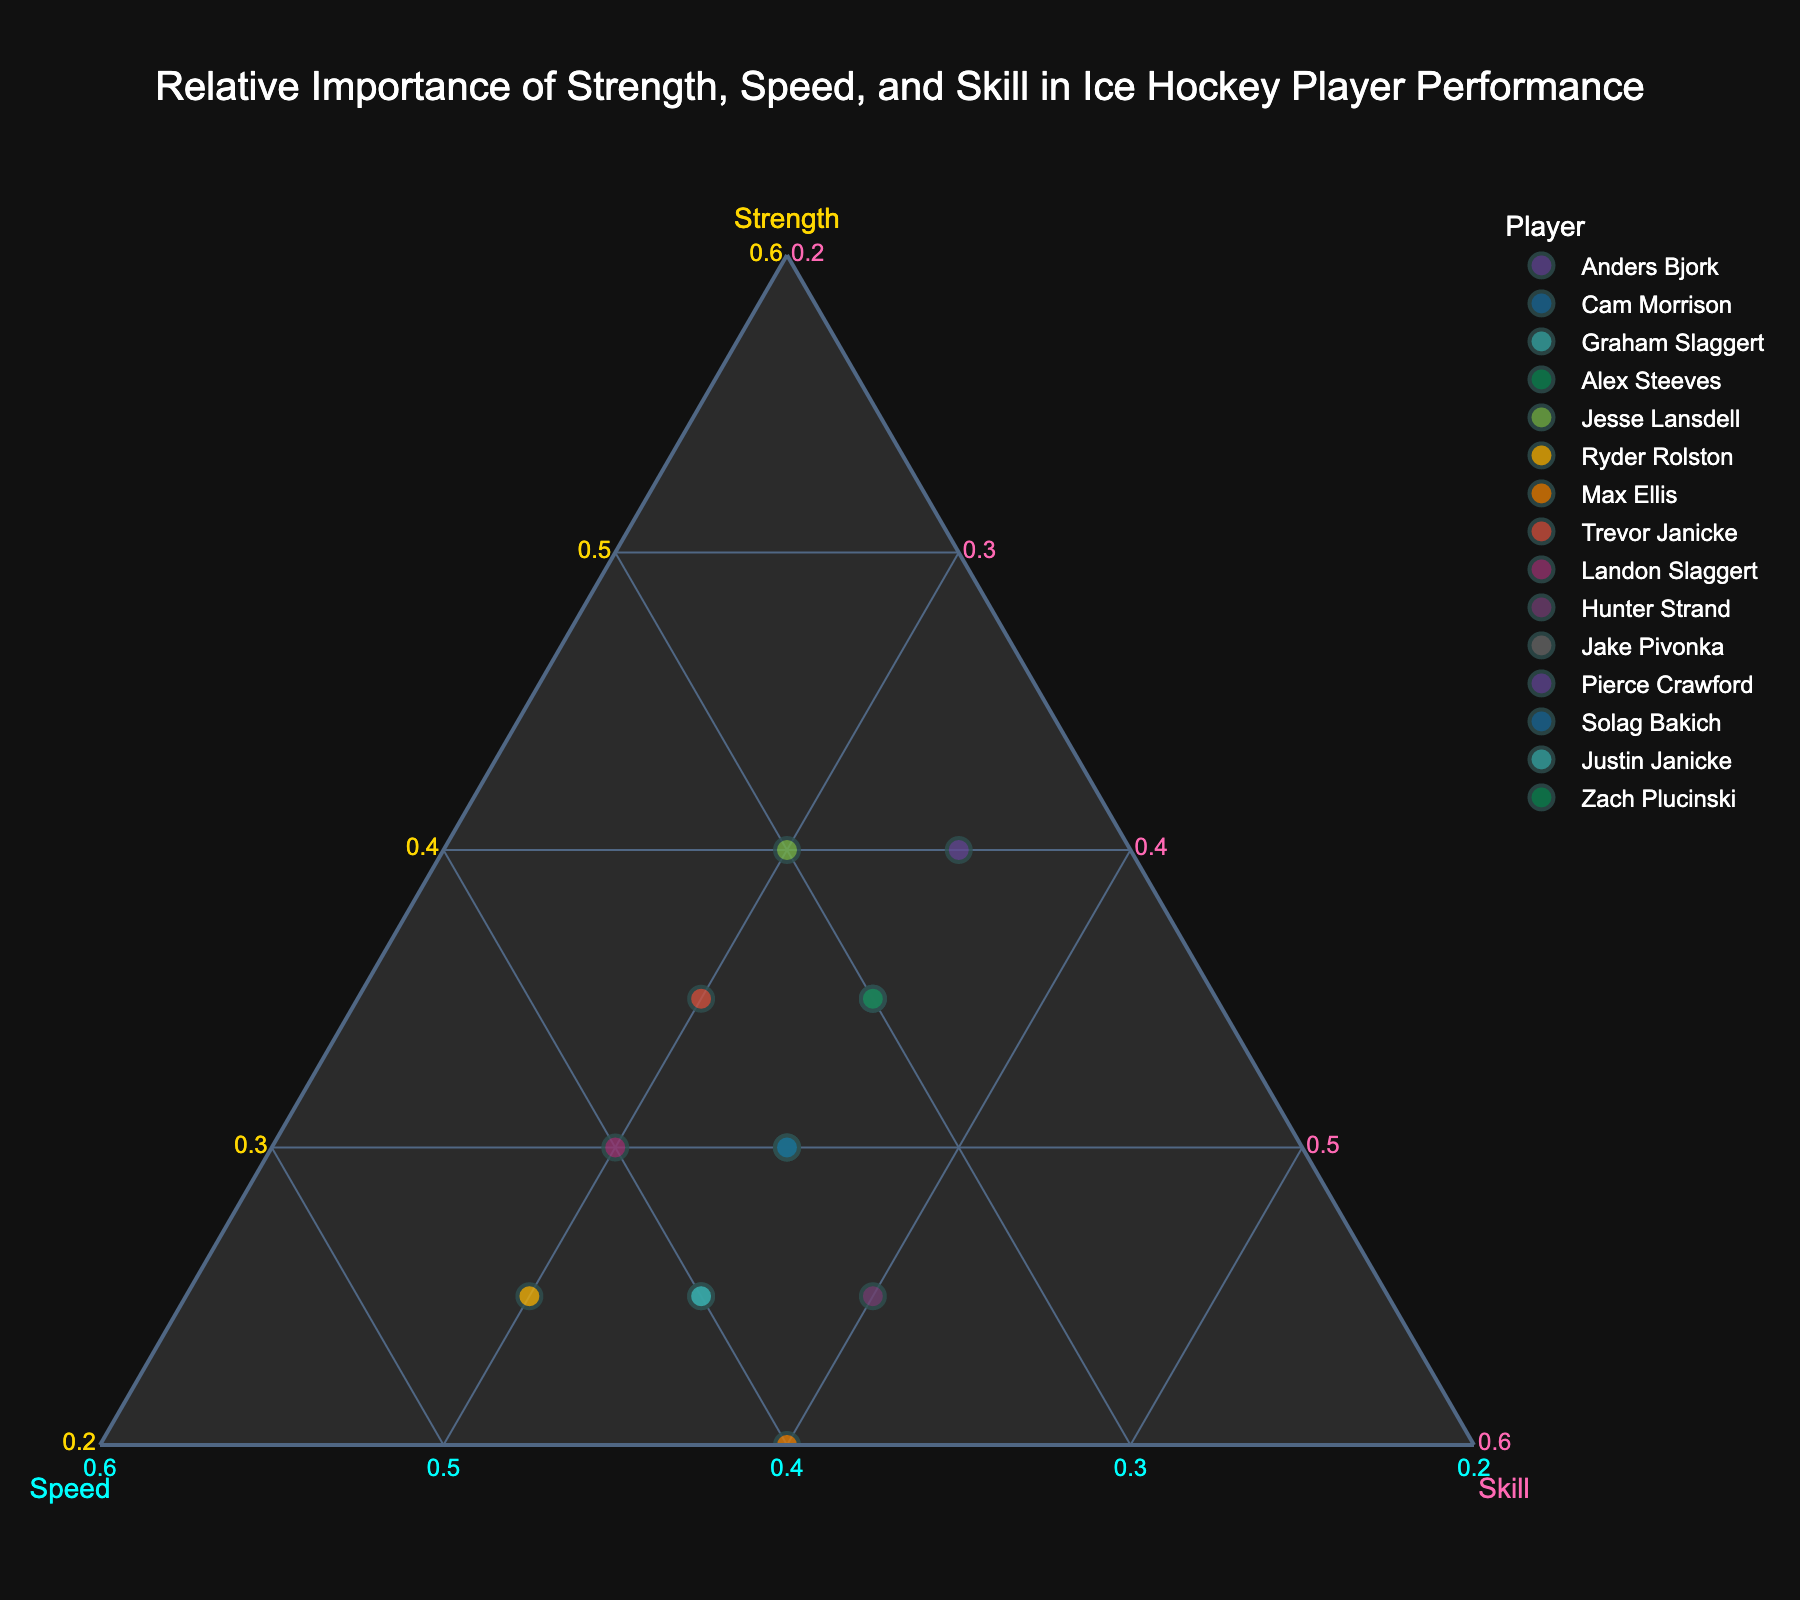What is the title of the plot? The title of the plot is written at the top within the plot area. From the given context, we can see it should be "Relative Importance of Strength, Speed, and Skill in Ice Hockey Player Performance".
Answer: Relative Importance of Strength, Speed, and Skill in Ice Hockey Player Performance What are the axis titles in the ternary plot? The axis titles are usually labeled on each of the three axes of a ternary plot. From the context provided, the axes should be labeled "Strength", "Speed", and "Skill".
Answer: Strength, Speed, Skill How many data points (players) are shown in the plot? There are 15 players provided in the data. Each player corresponds to a data point on the ternary plot, so there are 15 points in total.
Answer: 15 Which player has the highest value in the Speed axis? By examining the axis labeled "Speed" and identifying the data point closest to the maximum value, Ryder Rolston has the highest speed value of 45.
Answer: Ryder Rolston Which two players have the exactly same distribution of Strength, Speed, and Skill? By checking the plot for overlapping points, both Anders Bjork and Alex Steeves have the same values of 30 for Strength, 35 for Speed, and 35 for Skill.
Answer: Anders Bjork and Alex Steeves What's the average value of the Skill attribute across all players? To find the average value of Skill, sum all the Skill values and divide by the number of players (15). The sum is (35 + 35 + 35 + 35 + 30 + 30 + 40 + 30 + 30 + 40 + 35 + 35 + 35 + 35 + 35) = 525. Average is 525 / 15 = 35.
Answer: 35 Based on the plot, which player has equal values for Strength, Speed, and Skill? In the ternary plot, look for the player whose point is equally spaced from all three axis minima, indicating equal values for all attributes. Both Anders Bjork and Alex Steeves have equal values (30, 35, 35).
Answer: Anders Bjork and Alex Steeves Which players have higher Skill compared to Speed? Compare the positions of players with respect to the Skill and Speed axes. Max Ellis and Hunter Strand both have higher Skill (40) compared to their Speed (40 and 35, respectively).
Answer: Max Ellis and Hunter Strand 